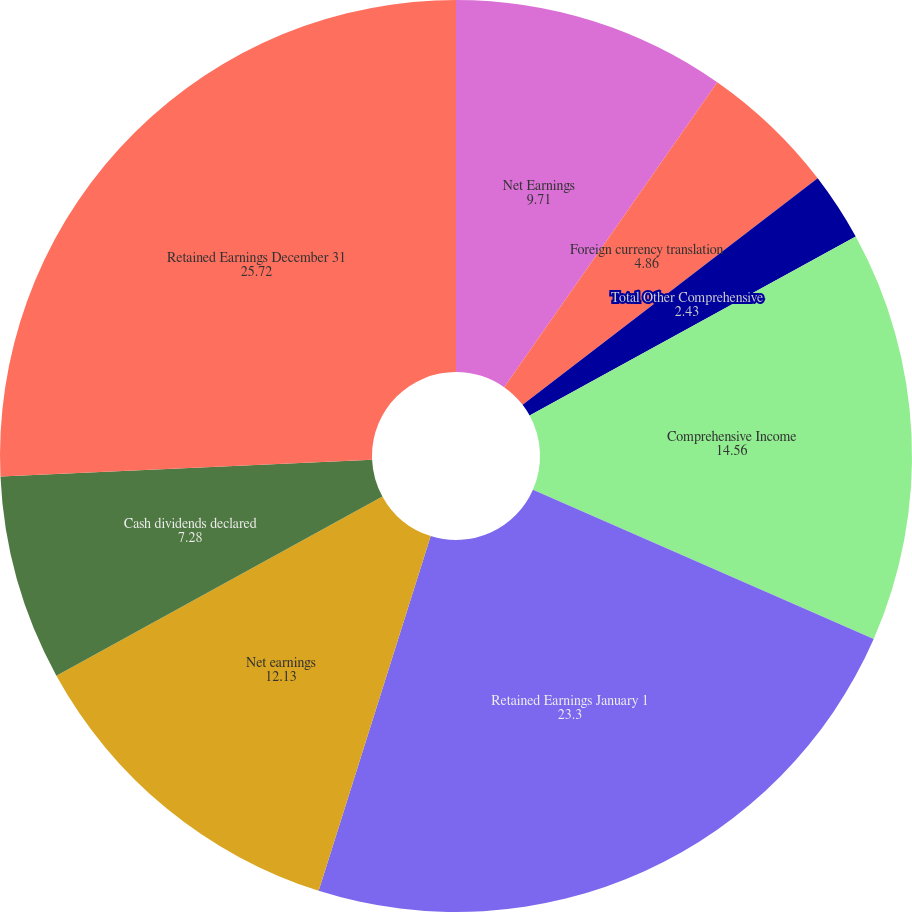Convert chart to OTSL. <chart><loc_0><loc_0><loc_500><loc_500><pie_chart><fcel>Net Earnings<fcel>Foreign currency translation<fcel>2006 and net of tax benefit of<fcel>Total Other Comprehensive<fcel>Comprehensive Income<fcel>Retained Earnings January 1<fcel>Net earnings<fcel>Cash dividends declared<fcel>Retained Earnings December 31<nl><fcel>9.71%<fcel>4.86%<fcel>0.01%<fcel>2.43%<fcel>14.56%<fcel>23.3%<fcel>12.13%<fcel>7.28%<fcel>25.72%<nl></chart> 